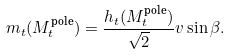Convert formula to latex. <formula><loc_0><loc_0><loc_500><loc_500>m _ { t } ( M _ { t } ^ { \text {pole} } ) = \frac { h _ { t } ( M _ { t } ^ { \text {pole} } ) } { \sqrt { 2 } } v \sin \beta .</formula> 